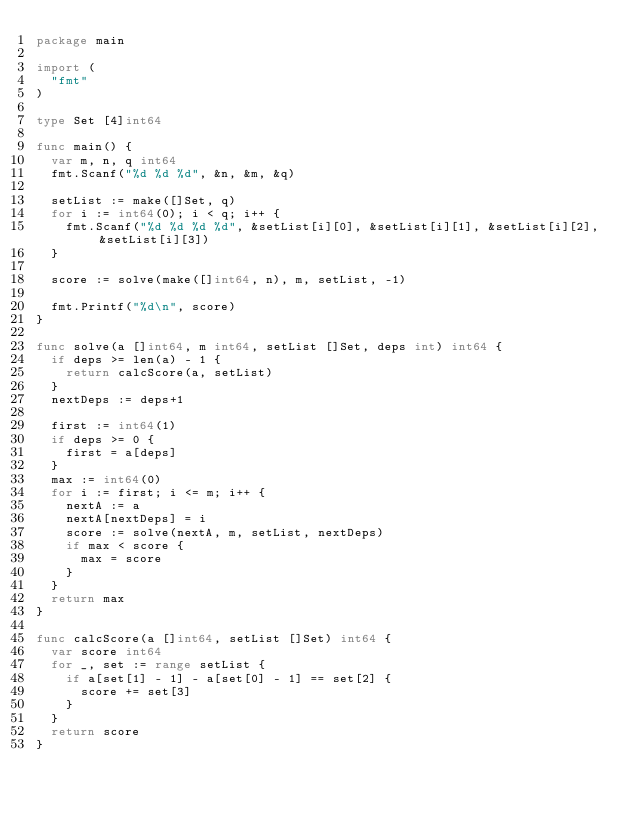Convert code to text. <code><loc_0><loc_0><loc_500><loc_500><_Go_>package main

import (
	"fmt"
)

type Set [4]int64

func main() {
	var m, n, q int64
	fmt.Scanf("%d %d %d", &n, &m, &q)

	setList := make([]Set, q)
	for i := int64(0); i < q; i++ {
		fmt.Scanf("%d %d %d %d", &setList[i][0], &setList[i][1], &setList[i][2], &setList[i][3])
	}

	score := solve(make([]int64, n), m, setList, -1)

	fmt.Printf("%d\n", score)
}

func solve(a []int64, m int64, setList []Set, deps int) int64 {
	if deps >= len(a) - 1 {
		return calcScore(a, setList)
	}
	nextDeps := deps+1

	first := int64(1)
	if deps >= 0 {
		first = a[deps]
	}
	max := int64(0)
	for i := first; i <= m; i++ {
		nextA := a
		nextA[nextDeps] = i
		score := solve(nextA, m, setList, nextDeps)
		if max < score {
			max = score
		}
	}
	return max
}

func calcScore(a []int64, setList []Set) int64 {
	var score int64
	for _, set := range setList {
		if a[set[1] - 1] - a[set[0] - 1] == set[2] {
			score += set[3]
		}
	}
	return score
}
</code> 